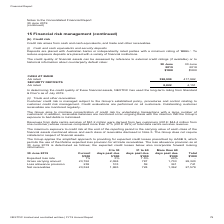According to Nextdc's financial document, How much was the security deposits in 2019? According to the financial document, 8,822 (in thousands). The relevant text states: "rated 398,999 417,982 SECURITY DEPOSITS AA rated 8,822 4,151..." Also, How much cash was at bank in 2019? According to the financial document, 398,999 (in thousands). The relevant text states: "CASH AT BANK AA rated 398,999 417,982 SECURITY DEPOSITS AA rated 8,822 4,151..." Also, How much was the security deposits in 2018? According to the financial document, 4,151 (in thousands). The relevant text states: "398,999 417,982 SECURITY DEPOSITS AA rated 8,822 4,151..." Also, can you calculate: What was the percentage change in AA rated security deposits between 2018 and 2019? To answer this question, I need to perform calculations using the financial data. The calculation is: (8,822 - 4,151) / 4,151 , which equals 112.53 (percentage). This is based on the information: "398,999 417,982 SECURITY DEPOSITS AA rated 8,822 4,151 rated 398,999 417,982 SECURITY DEPOSITS AA rated 8,822 4,151..." The key data points involved are: 4,151, 8,822. Additionally, Cash at bank or security deposits, which one was greater in 2019? According to the financial document, Cash at bank. The relevant text states: "CASH AT BANK AA rated 398,999 417,982 SECURITY DEPOSITS AA rated 8,822 4,151..." Also, can you calculate: What was the average difference between cash at bank and security deposits for both years? To answer this question, I need to perform calculations using the financial data. The calculation is: ((398,999 - 8,822) + (417,982 - 4,151)) / 2 , which equals 402004 (in thousands). This is based on the information: "398,999 417,982 SECURITY DEPOSITS AA rated 8,822 4,151 CASH AT BANK AA rated 398,999 417,982 SECURITY DEPOSITS AA rated 8,822 4,151 CASH AT BANK AA rated 398,999 417,982 SECURITY DEPOSITS AA rated 8,8..." The key data points involved are: 398,999, 4,151, 417,982. 